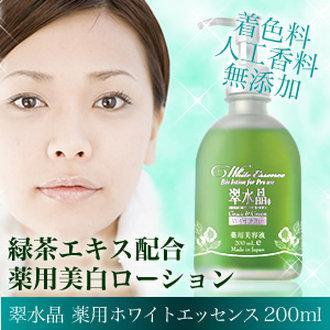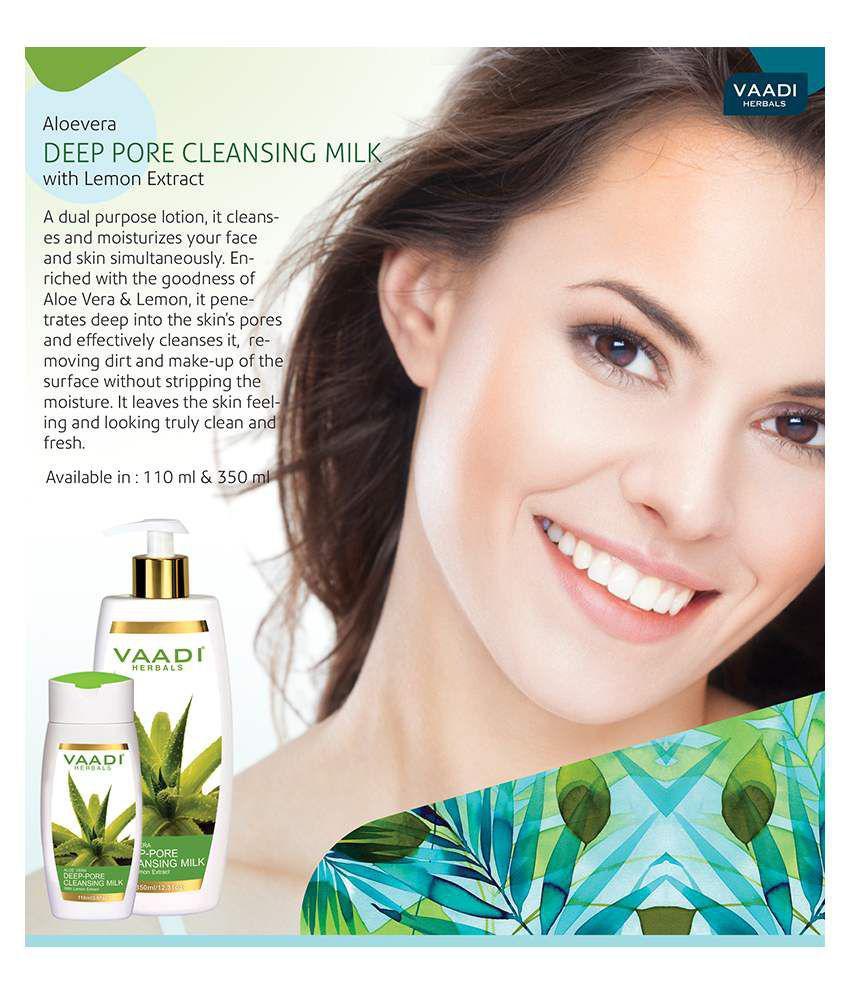The first image is the image on the left, the second image is the image on the right. Considering the images on both sides, is "At least one woman has her hand on her face." valid? Answer yes or no. No. The first image is the image on the left, the second image is the image on the right. Given the left and right images, does the statement "An ad image shows a model with slicked-back hair holding exactly one hand on her cheek." hold true? Answer yes or no. No. 